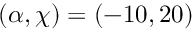Convert formula to latex. <formula><loc_0><loc_0><loc_500><loc_500>( \alpha , \chi ) = ( - 1 0 , 2 0 )</formula> 